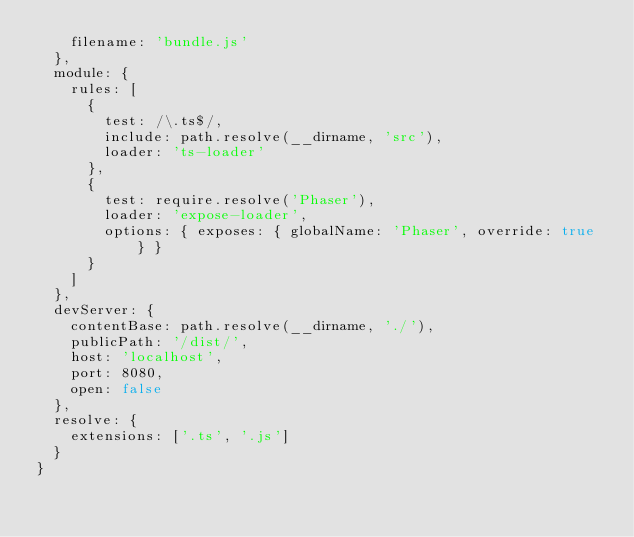<code> <loc_0><loc_0><loc_500><loc_500><_JavaScript_>    filename: 'bundle.js'
  },
  module: {
    rules: [
      {
        test: /\.ts$/,
        include: path.resolve(__dirname, 'src'),
        loader: 'ts-loader'
      },
      {
        test: require.resolve('Phaser'),
        loader: 'expose-loader',
        options: { exposes: { globalName: 'Phaser', override: true } }
      }
    ]
  },
  devServer: {
    contentBase: path.resolve(__dirname, './'),
    publicPath: '/dist/',
    host: 'localhost',
    port: 8080,
    open: false
  },
  resolve: {
    extensions: ['.ts', '.js']
  }
}
</code> 